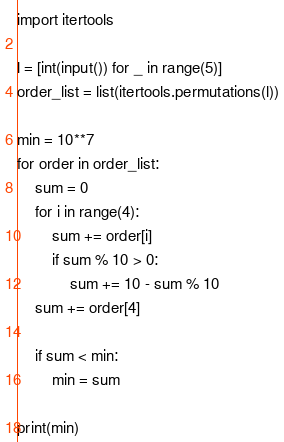<code> <loc_0><loc_0><loc_500><loc_500><_Python_>import itertools

l = [int(input()) for _ in range(5)]
order_list = list(itertools.permutations(l))

min = 10**7
for order in order_list:
    sum = 0
    for i in range(4):
        sum += order[i]
        if sum % 10 > 0:
            sum += 10 - sum % 10
    sum += order[4]

    if sum < min:
        min = sum

print(min)
</code> 